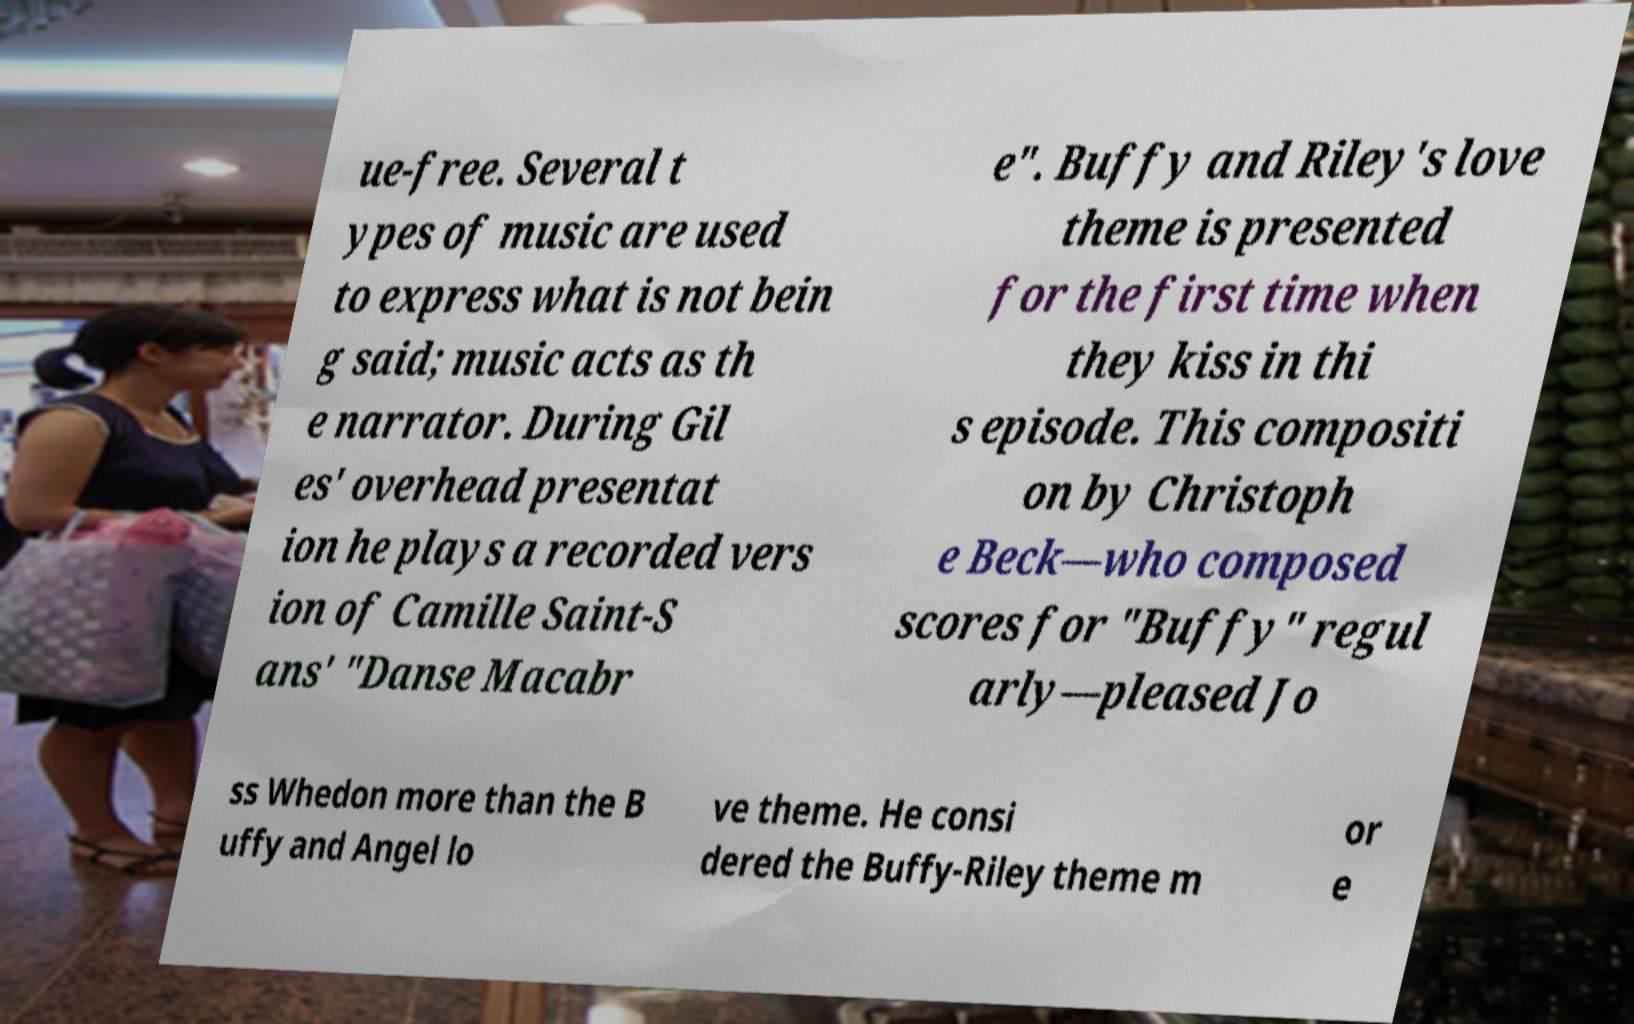For documentation purposes, I need the text within this image transcribed. Could you provide that? ue-free. Several t ypes of music are used to express what is not bein g said; music acts as th e narrator. During Gil es' overhead presentat ion he plays a recorded vers ion of Camille Saint-S ans' "Danse Macabr e". Buffy and Riley's love theme is presented for the first time when they kiss in thi s episode. This compositi on by Christoph e Beck—who composed scores for "Buffy" regul arly—pleased Jo ss Whedon more than the B uffy and Angel lo ve theme. He consi dered the Buffy-Riley theme m or e 